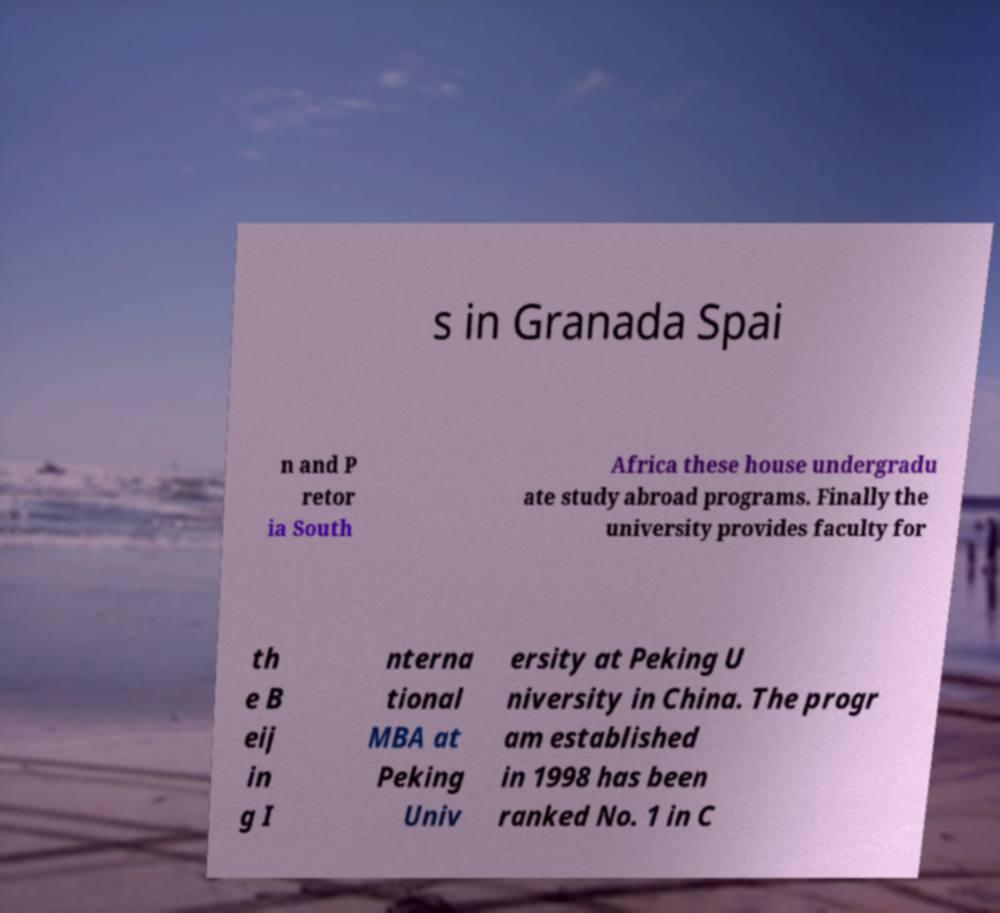Can you accurately transcribe the text from the provided image for me? s in Granada Spai n and P retor ia South Africa these house undergradu ate study abroad programs. Finally the university provides faculty for th e B eij in g I nterna tional MBA at Peking Univ ersity at Peking U niversity in China. The progr am established in 1998 has been ranked No. 1 in C 